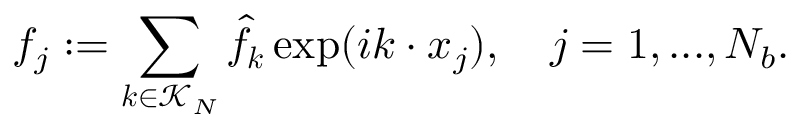Convert formula to latex. <formula><loc_0><loc_0><loc_500><loc_500>f _ { j } \colon = \sum _ { \boldsymbol k \in \mathcal { K } _ { N } } \hat { f } _ { \boldsymbol k } \exp ( i \boldsymbol k \cdot \boldsymbol x _ { j } ) , \quad j = 1 , \dots , N _ { b } .</formula> 